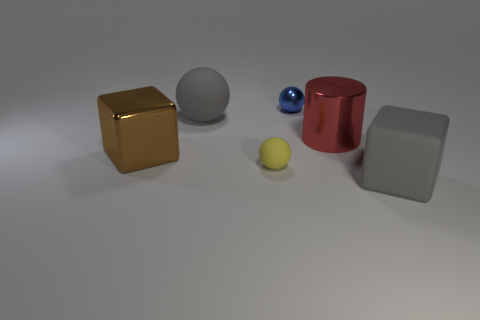Add 3 big rubber spheres. How many objects exist? 9 Subtract all cubes. How many objects are left? 4 Add 1 matte balls. How many matte balls are left? 3 Add 4 tiny purple rubber things. How many tiny purple rubber things exist? 4 Subtract 0 blue cylinders. How many objects are left? 6 Subtract all tiny blue metallic balls. Subtract all large gray rubber objects. How many objects are left? 3 